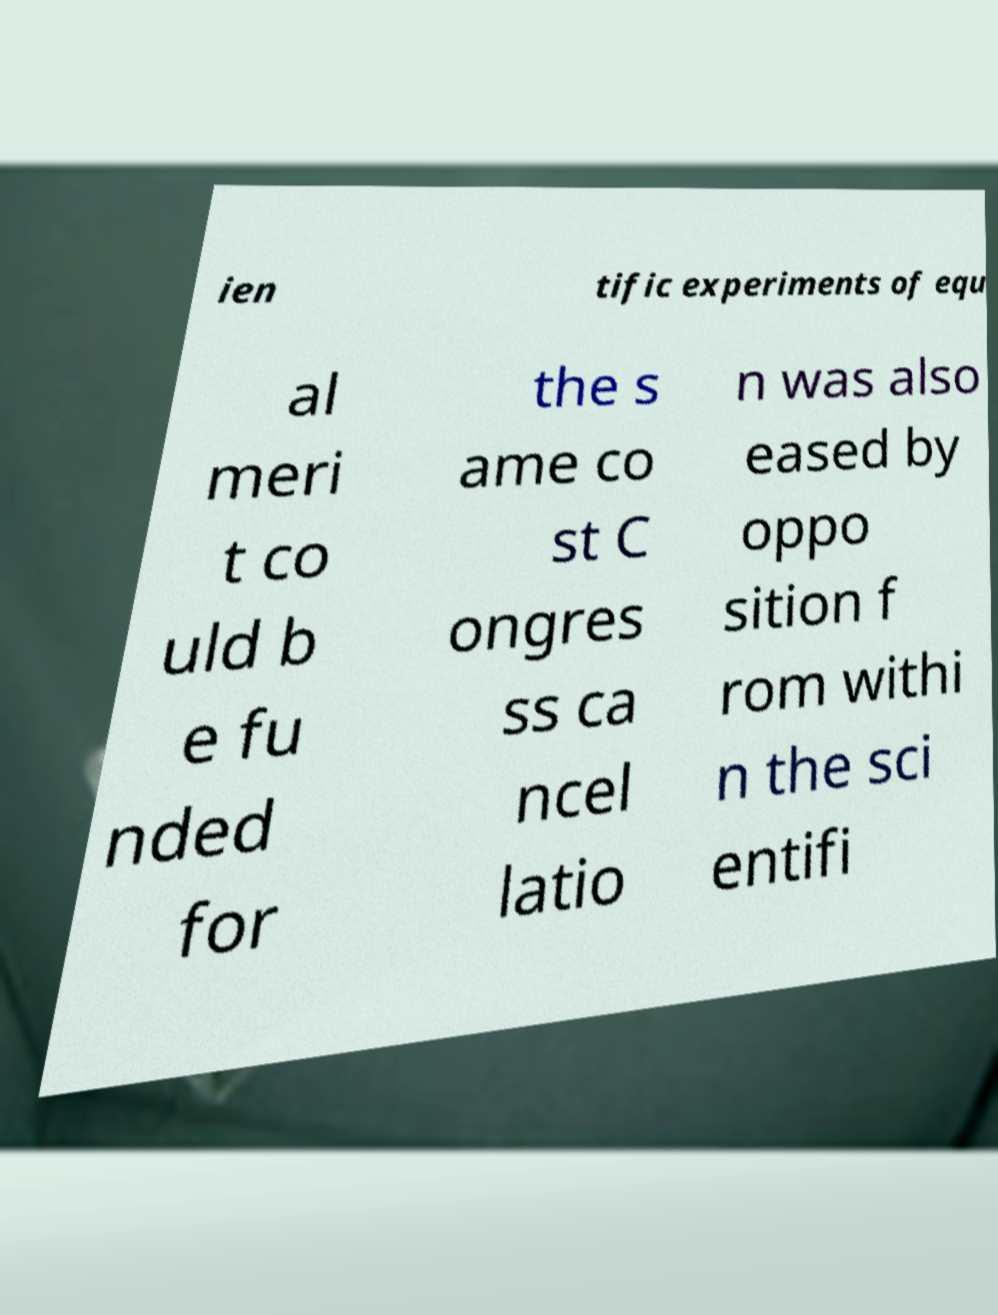Could you extract and type out the text from this image? ien tific experiments of equ al meri t co uld b e fu nded for the s ame co st C ongres ss ca ncel latio n was also eased by oppo sition f rom withi n the sci entifi 